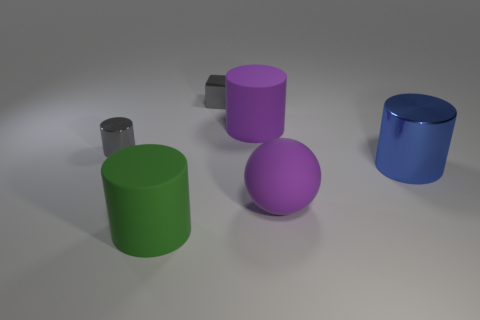Subtract all brown cylinders. Subtract all cyan cubes. How many cylinders are left? 4 Add 4 tiny objects. How many objects exist? 10 Subtract all cylinders. How many objects are left? 2 Subtract all cylinders. Subtract all matte cylinders. How many objects are left? 0 Add 6 metal objects. How many metal objects are left? 9 Add 5 small purple matte cylinders. How many small purple matte cylinders exist? 5 Subtract 0 green spheres. How many objects are left? 6 